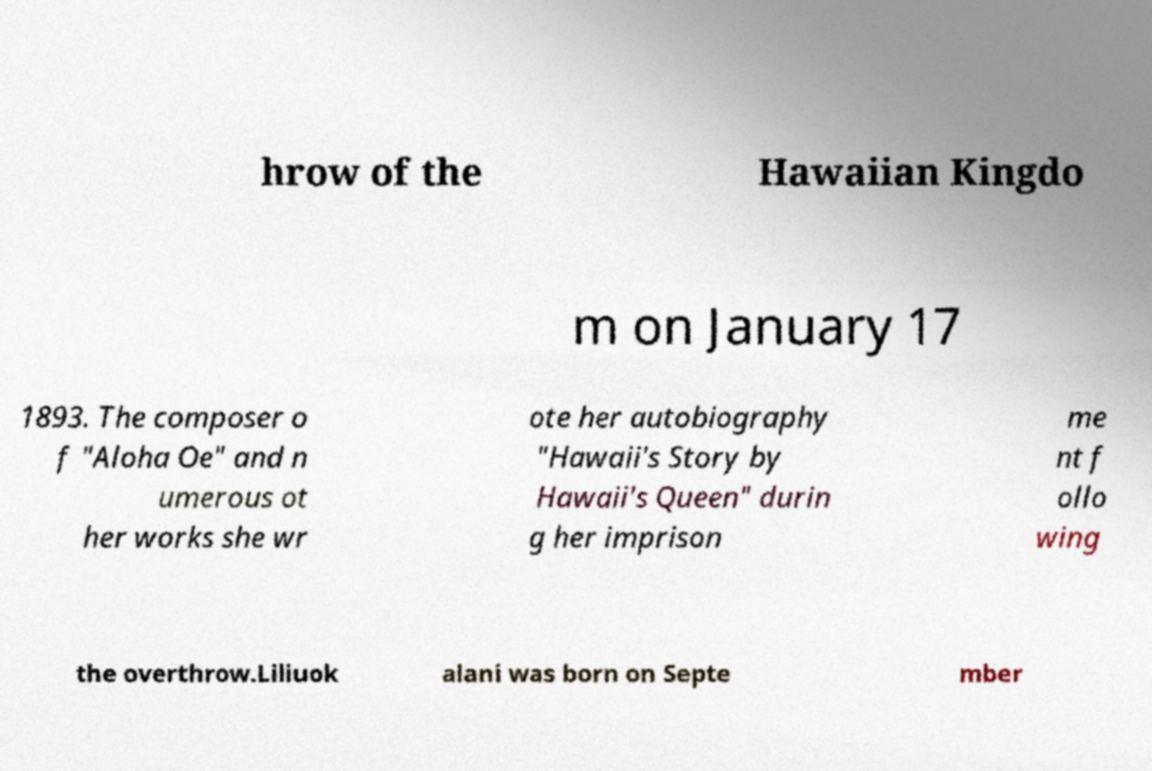Could you assist in decoding the text presented in this image and type it out clearly? hrow of the Hawaiian Kingdo m on January 17 1893. The composer o f "Aloha Oe" and n umerous ot her works she wr ote her autobiography "Hawaii's Story by Hawaii's Queen" durin g her imprison me nt f ollo wing the overthrow.Liliuok alani was born on Septe mber 